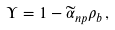Convert formula to latex. <formula><loc_0><loc_0><loc_500><loc_500>\Upsilon = 1 - \widetilde { \alpha } _ { n p } \rho _ { b } \, ,</formula> 